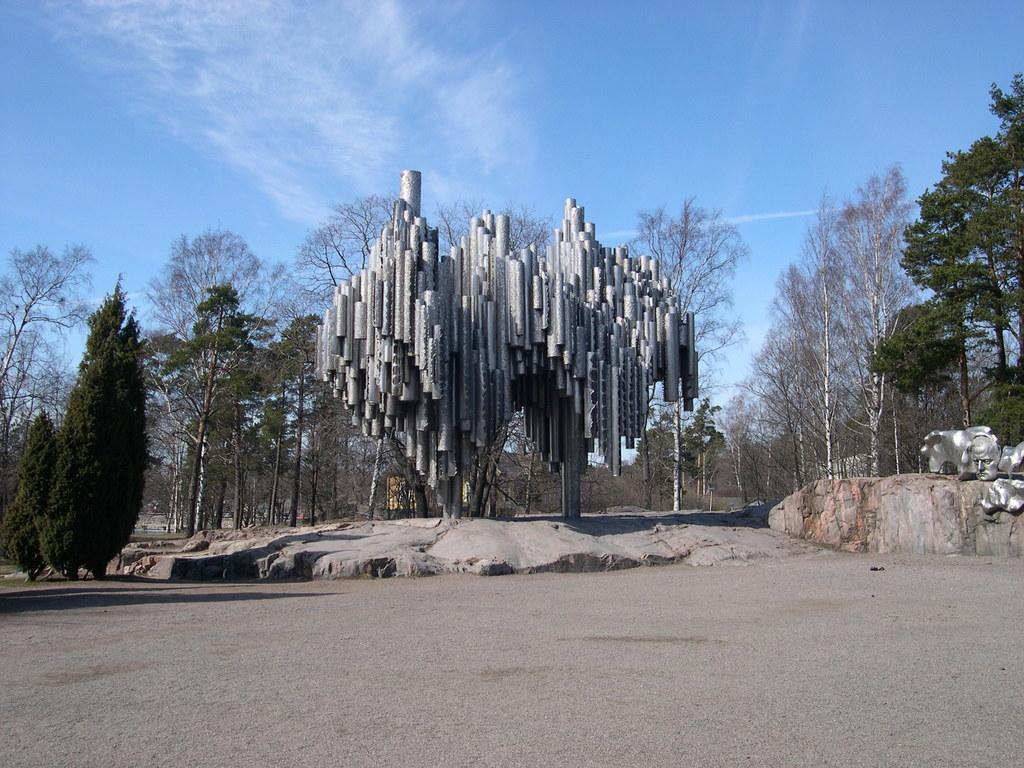Please provide a concise description of this image. In this image I can see the ground, few trees which are green in color, a silver colored structure which is in the shape of human face on the rock and an silver colored object which is made up of pipes. In the background I can see the sky. 